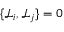Convert formula to latex. <formula><loc_0><loc_0><loc_500><loc_500>\{ \mathcal { L } _ { i } , \mathcal { L } _ { j } \} = 0</formula> 